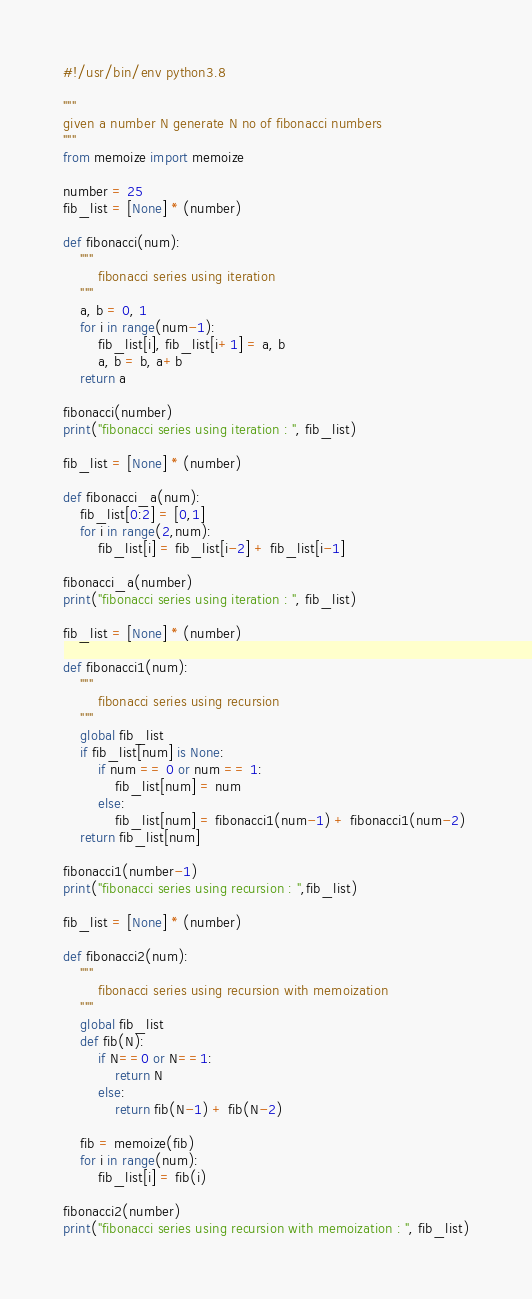Convert code to text. <code><loc_0><loc_0><loc_500><loc_500><_Python_>#!/usr/bin/env python3.8

"""
given a number N generate N no of fibonacci numbers
"""
from memoize import memoize

number = 25
fib_list = [None] * (number)

def fibonacci(num):
	"""
		fibonacci series using iteration
	"""
	a, b = 0, 1
	for i in range(num-1):
		fib_list[i], fib_list[i+1] = a, b
		a, b = b, a+b
	return a

fibonacci(number)
print("fibonacci series using iteration : ", fib_list)

fib_list = [None] * (number)

def fibonacci_a(num):
	fib_list[0:2] = [0,1]
	for i in range(2,num):
		fib_list[i] = fib_list[i-2] + fib_list[i-1]

fibonacci_a(number)
print("fibonacci series using iteration : ", fib_list)

fib_list = [None] * (number)

def fibonacci1(num):
	"""
		fibonacci series using recursion
	"""
	global fib_list
	if fib_list[num] is None:
		if num == 0 or num == 1:
			fib_list[num] = num
		else:
			fib_list[num] = fibonacci1(num-1) + fibonacci1(num-2)
	return fib_list[num]

fibonacci1(number-1)
print("fibonacci series using recursion : ",fib_list)

fib_list = [None] * (number)

def fibonacci2(num):
	"""
		fibonacci series using recursion with memoization
	"""
	global fib_list
	def fib(N):
		if N==0 or N==1:
			return N
		else:
			return fib(N-1) + fib(N-2)

	fib = memoize(fib)
	for i in range(num):
		fib_list[i] = fib(i)

fibonacci2(number)
print("fibonacci series using recursion with memoization : ", fib_list)</code> 